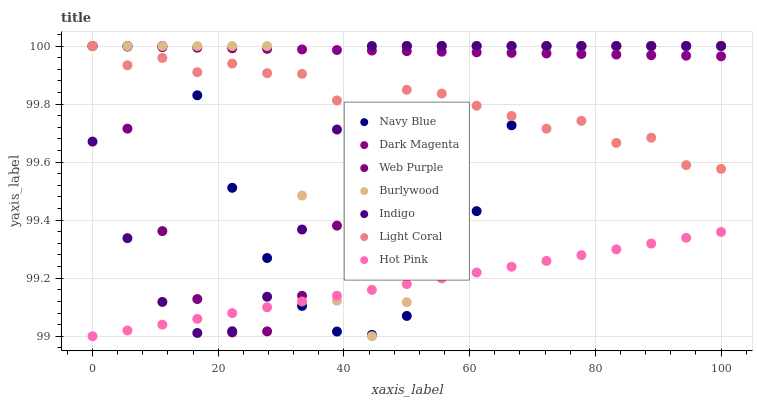Does Hot Pink have the minimum area under the curve?
Answer yes or no. Yes. Does Dark Magenta have the maximum area under the curve?
Answer yes or no. Yes. Does Burlywood have the minimum area under the curve?
Answer yes or no. No. Does Burlywood have the maximum area under the curve?
Answer yes or no. No. Is Hot Pink the smoothest?
Answer yes or no. Yes. Is Burlywood the roughest?
Answer yes or no. Yes. Is Dark Magenta the smoothest?
Answer yes or no. No. Is Dark Magenta the roughest?
Answer yes or no. No. Does Hot Pink have the lowest value?
Answer yes or no. Yes. Does Burlywood have the lowest value?
Answer yes or no. No. Does Web Purple have the highest value?
Answer yes or no. Yes. Does Hot Pink have the highest value?
Answer yes or no. No. Is Hot Pink less than Light Coral?
Answer yes or no. Yes. Is Dark Magenta greater than Hot Pink?
Answer yes or no. Yes. Does Dark Magenta intersect Light Coral?
Answer yes or no. Yes. Is Dark Magenta less than Light Coral?
Answer yes or no. No. Is Dark Magenta greater than Light Coral?
Answer yes or no. No. Does Hot Pink intersect Light Coral?
Answer yes or no. No. 